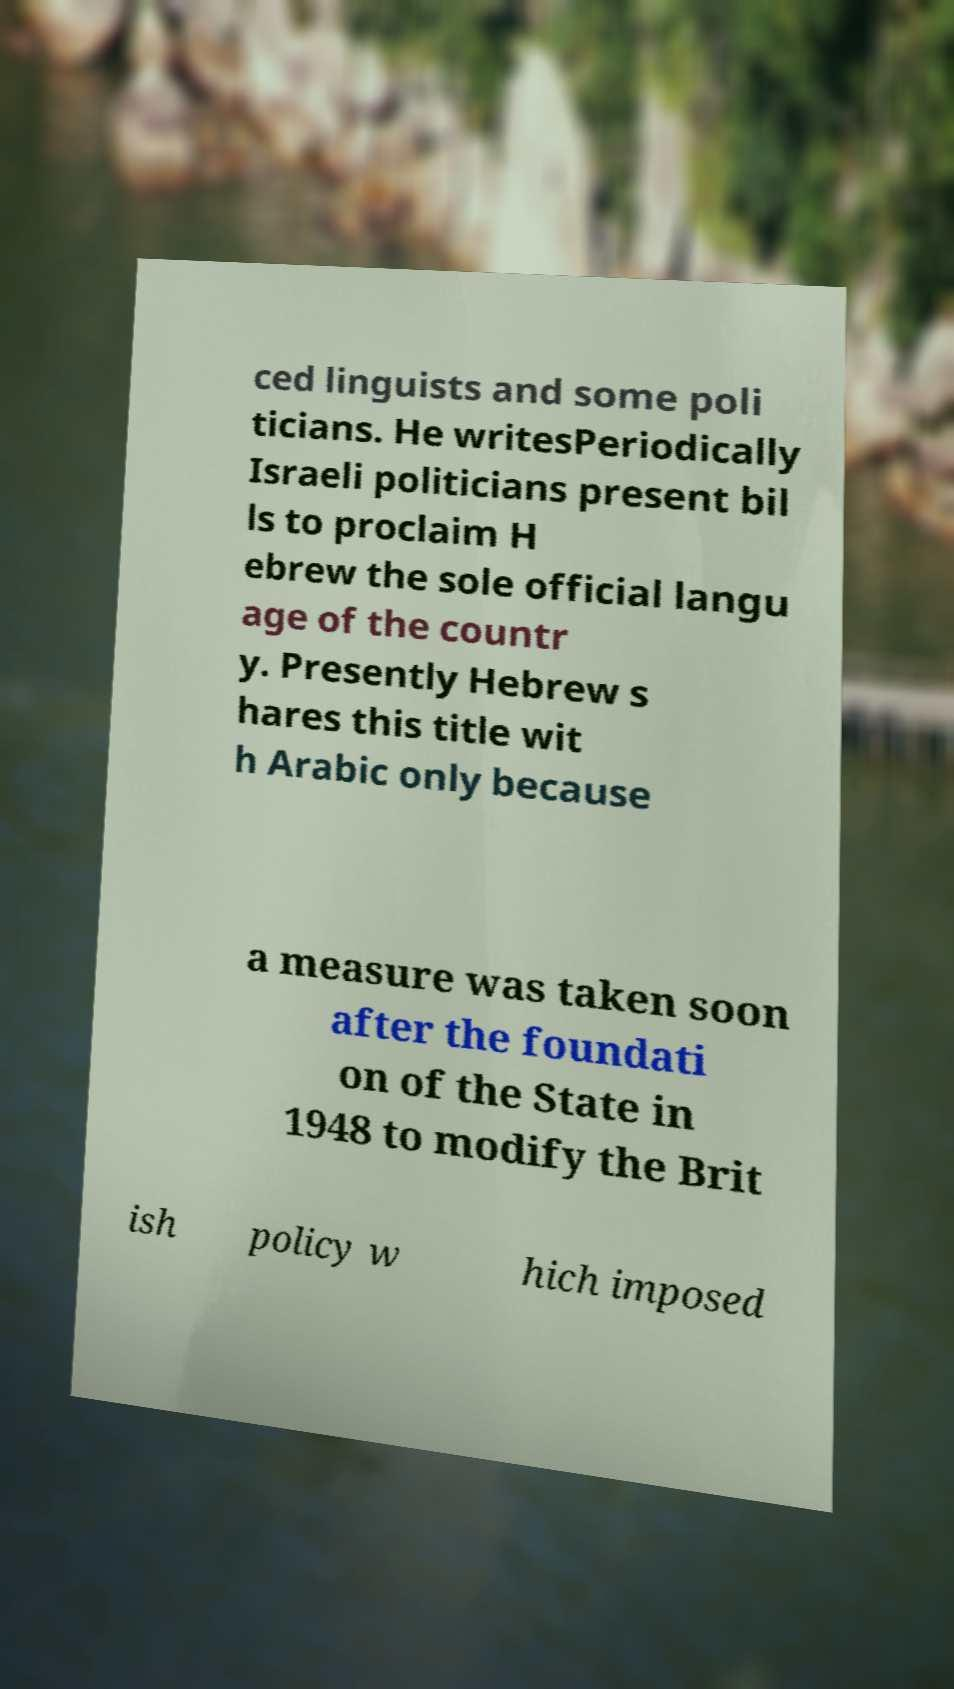There's text embedded in this image that I need extracted. Can you transcribe it verbatim? ced linguists and some poli ticians. He writesPeriodically Israeli politicians present bil ls to proclaim H ebrew the sole official langu age of the countr y. Presently Hebrew s hares this title wit h Arabic only because a measure was taken soon after the foundati on of the State in 1948 to modify the Brit ish policy w hich imposed 